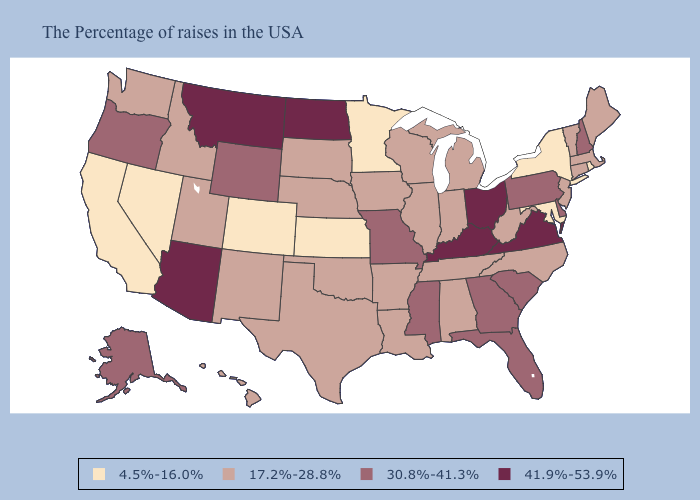Which states have the highest value in the USA?
Concise answer only. Virginia, Ohio, Kentucky, North Dakota, Montana, Arizona. Name the states that have a value in the range 30.8%-41.3%?
Give a very brief answer. New Hampshire, Delaware, Pennsylvania, South Carolina, Florida, Georgia, Mississippi, Missouri, Wyoming, Oregon, Alaska. Name the states that have a value in the range 41.9%-53.9%?
Answer briefly. Virginia, Ohio, Kentucky, North Dakota, Montana, Arizona. Name the states that have a value in the range 41.9%-53.9%?
Give a very brief answer. Virginia, Ohio, Kentucky, North Dakota, Montana, Arizona. Among the states that border Oregon , does Nevada have the highest value?
Quick response, please. No. What is the highest value in states that border Rhode Island?
Concise answer only. 17.2%-28.8%. What is the value of New Hampshire?
Give a very brief answer. 30.8%-41.3%. Name the states that have a value in the range 41.9%-53.9%?
Answer briefly. Virginia, Ohio, Kentucky, North Dakota, Montana, Arizona. Among the states that border Oregon , does Nevada have the lowest value?
Write a very short answer. Yes. What is the lowest value in the USA?
Give a very brief answer. 4.5%-16.0%. What is the lowest value in the USA?
Be succinct. 4.5%-16.0%. Does the map have missing data?
Keep it brief. No. Does Utah have the lowest value in the West?
Keep it brief. No. Does Maryland have the lowest value in the USA?
Write a very short answer. Yes. Which states hav the highest value in the MidWest?
Concise answer only. Ohio, North Dakota. 